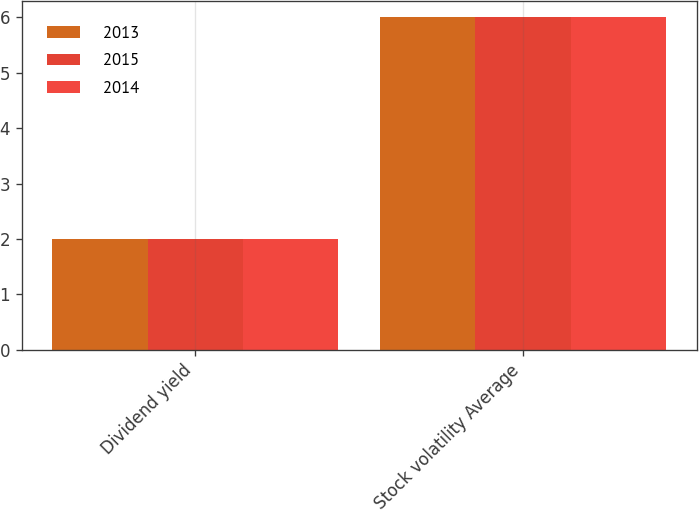Convert chart. <chart><loc_0><loc_0><loc_500><loc_500><stacked_bar_chart><ecel><fcel>Dividend yield<fcel>Stock volatility Average<nl><fcel>2013<fcel>2<fcel>6<nl><fcel>2015<fcel>2<fcel>6<nl><fcel>2014<fcel>2<fcel>6<nl></chart> 